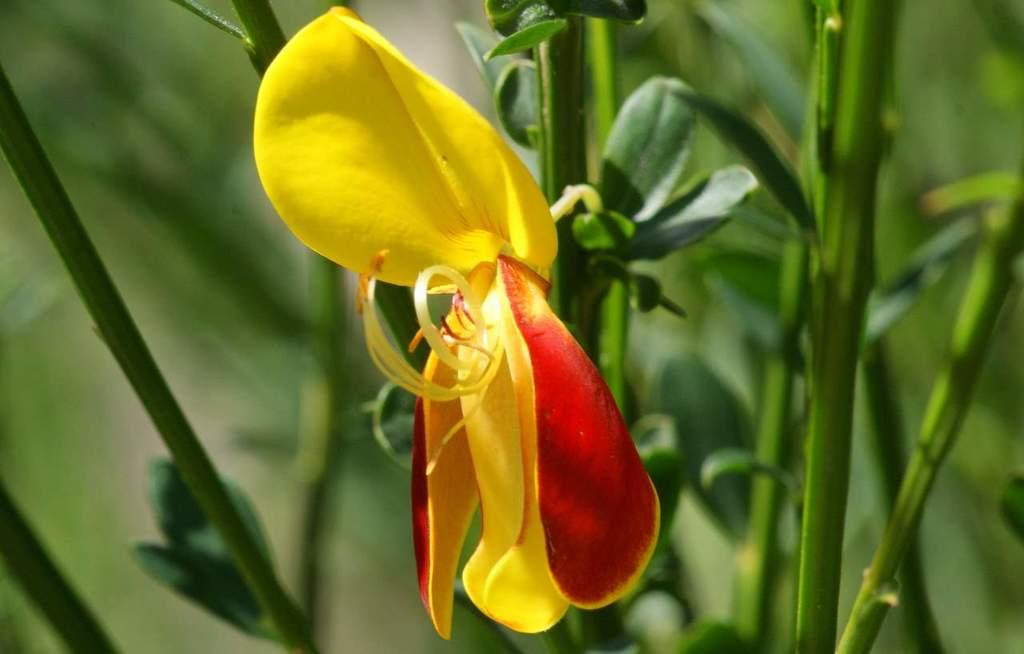What is the main subject of the image? The main subject of the image is a flower. Can you describe the colors of the flower? The flower has yellow and red colors. How would you describe the background of the image? The background of the image is blurry. What type of notebook does the flower's brother use in the image? There is no mention of a notebook or a brother in the image, so this question cannot be answered. 